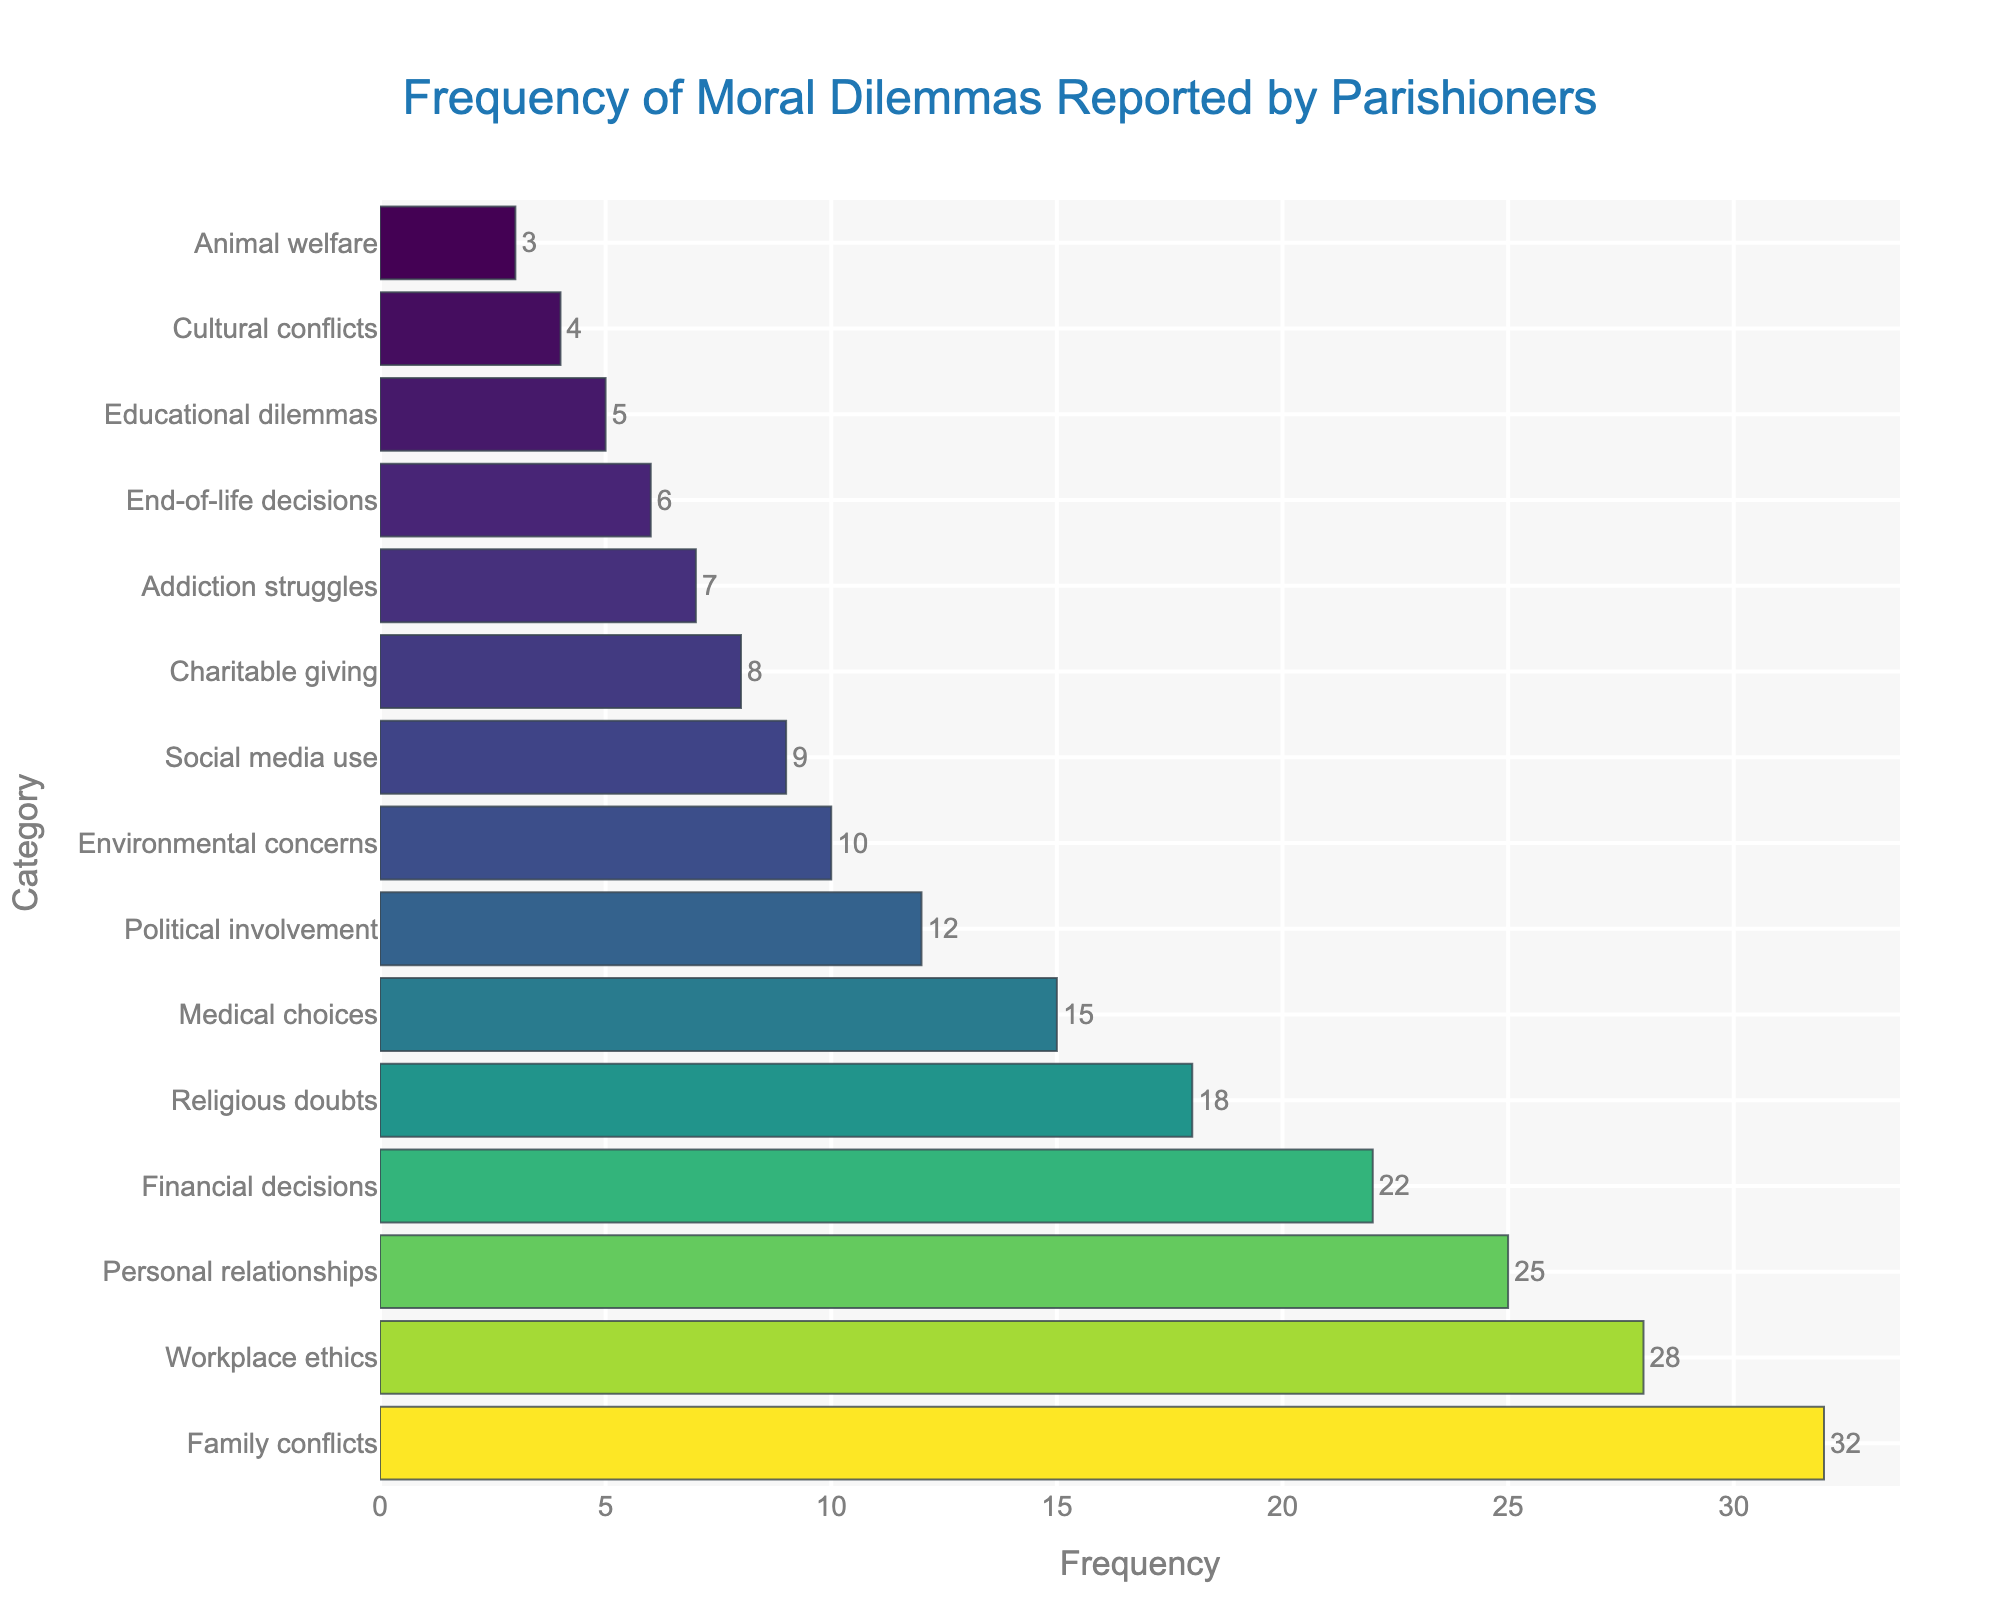Which category has the highest frequency? The highest frequency corresponds to the tallest bar in the bar chart. The tallest bar is colored most intensely and is labeled "Family conflicts" with a frequency of 32.
Answer: Family conflicts Which category shows the least frequency of moral dilemmas reported by parishioners? The category with the least frequency will be the shortest bar in the chart. The shortest bar is labeled "Animal welfare" with a frequency of 3.
Answer: Animal welfare How many more reports are there for "Family conflicts" than for "Educational dilemmas"? To find the difference, subtract the frequency of "Educational dilemmas" from the frequency of "Family conflicts". "Family conflicts" has a frequency of 32 and "Educational dilemmas" has a frequency of 5. The difference is 32 - 5 = 27.
Answer: 27 What is the combined frequency of "Financial decisions" and "Medical choices"? Add the frequencies of "Financial decisions" (22) and "Medical choices" (15). The sum is 22 + 15 = 37.
Answer: 37 Which category appears with a frequency closest to the average frequency of all moral dilemmas? First, calculate the average frequency. The sum of all frequencies is 32 + 28 + 25 + 22 + 18 + 15 + 12 + 10 + 9 + 8 + 7 + 6 + 5 + 4 + 3 = 194. There are 15 categories, so the average is 194 / 15 ≈ 12.93. The category with a frequency closest to this average is "Political involvement" with a frequency of 12.
Answer: Political involvement Which category is reported more often, "Personal relationships" or "Religious doubts"? Compare the frequencies of "Personal relationships" (25) and "Religious doubts" (18). Since 25 is greater than 18, "Personal relationships" is reported more often.
Answer: Personal relationships What is the total frequency of moral dilemmas related to "Environmental concerns", "Cultural conflicts", and "Animal welfare"? Add the frequencies of "Environmental concerns" (10), "Cultural conflicts" (4), and "Animal welfare" (3). The total is 10 + 4 + 3 = 17.
Answer: 17 How does the frequency of "Addiction struggles" compare to the median frequency of the categories? To find the median, order the frequencies and find the middle value. The ordered frequencies are 3, 4, 5, 6, 7, 8, 9, 10, 12, 15, 18, 22, 25, 28, 32. The median frequency (the 8th value) is 10. "Addiction struggles" has a frequency of 7, which is less than the median.
Answer: Less than Is the frequency of "Workplace ethics" higher than twice the frequency of "Charitable giving"? Find twice the frequency of "Charitable giving" by multiplying its frequency by 2 (8 * 2 = 16), then compare it with "Workplace ethics" (28). Since 28 > 16, "Workplace ethics" frequency is higher.
Answer: Yes 